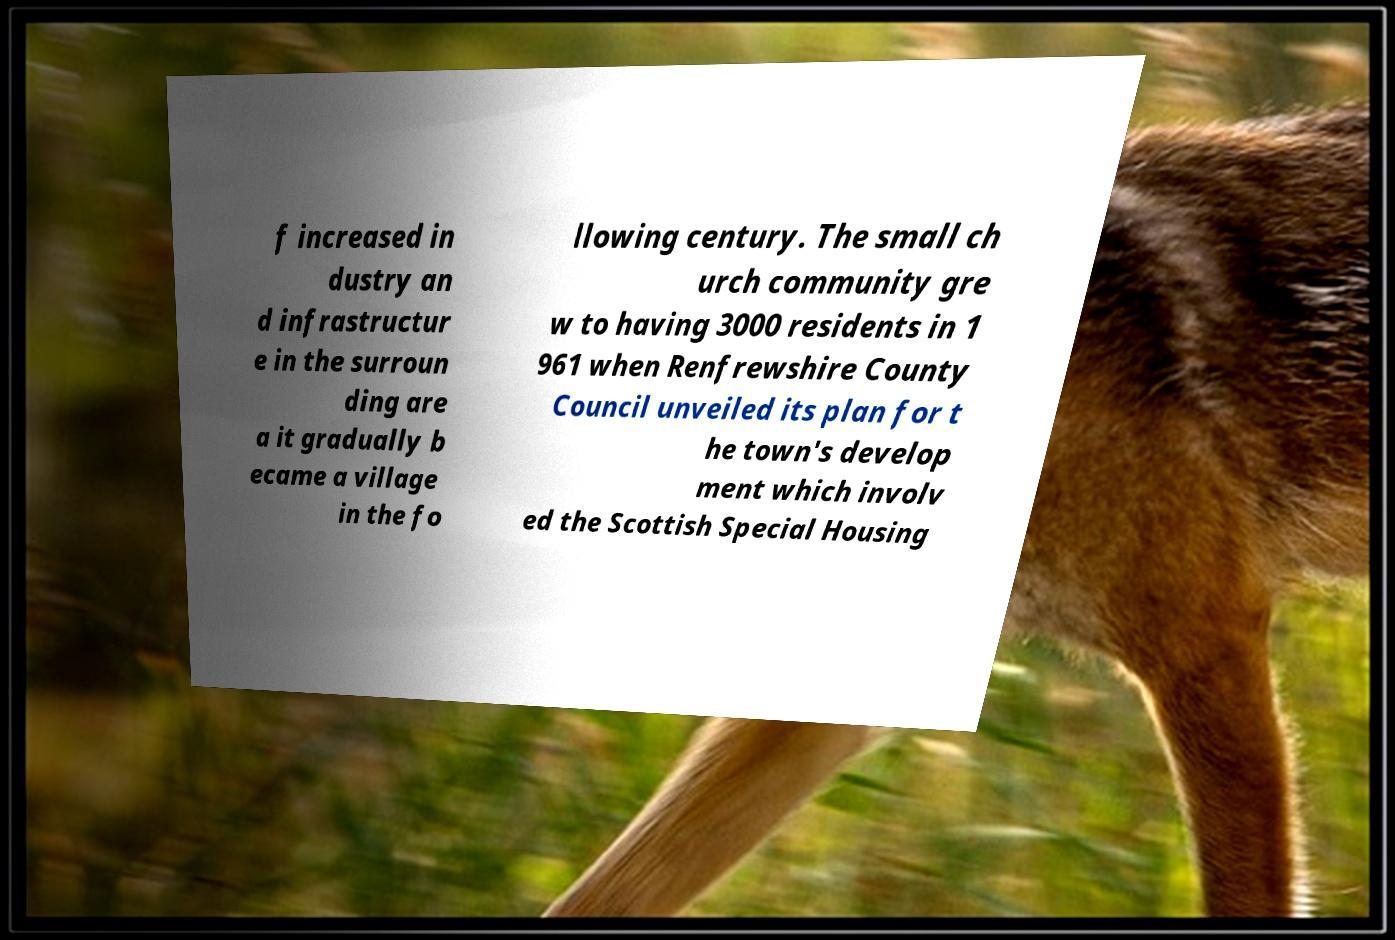Can you accurately transcribe the text from the provided image for me? f increased in dustry an d infrastructur e in the surroun ding are a it gradually b ecame a village in the fo llowing century. The small ch urch community gre w to having 3000 residents in 1 961 when Renfrewshire County Council unveiled its plan for t he town's develop ment which involv ed the Scottish Special Housing 